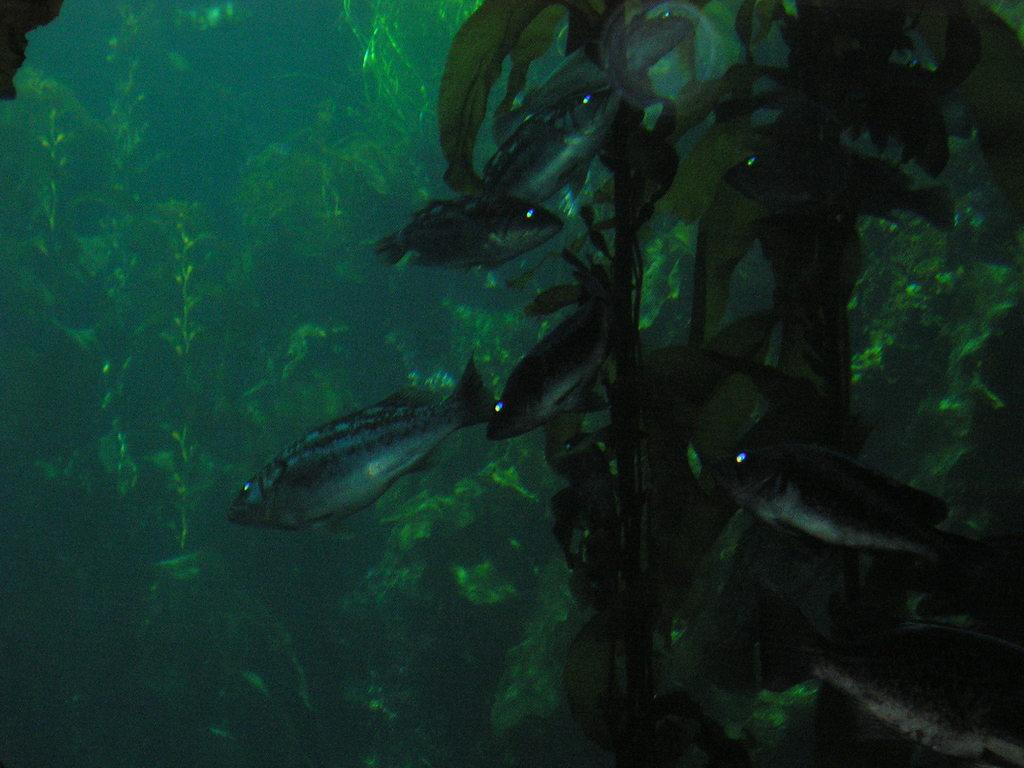How many fishes can be seen in the underwater scene? There are four fishes in the underwater. What else can be seen in the background besides the fishes? There is a plant and algae in the background. Are there any plants visible in the sea water? Yes, there are green plants in the sea water. What is the temper of the ocean in the image? There is no ocean present in the image, as it is an underwater scene with fishes and plants. 